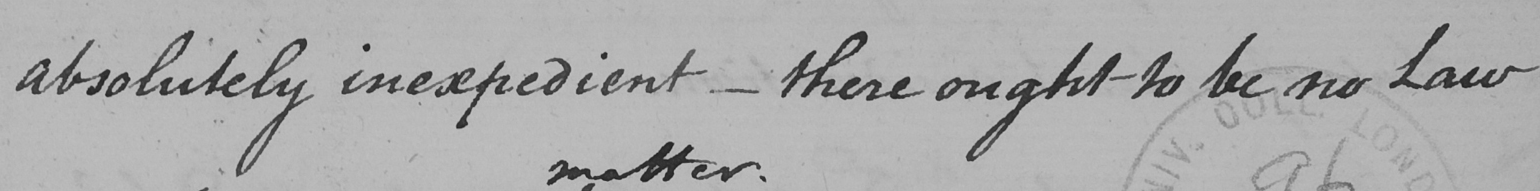Please transcribe the handwritten text in this image. absolutely inexpedient  _  there ought to be no Law 